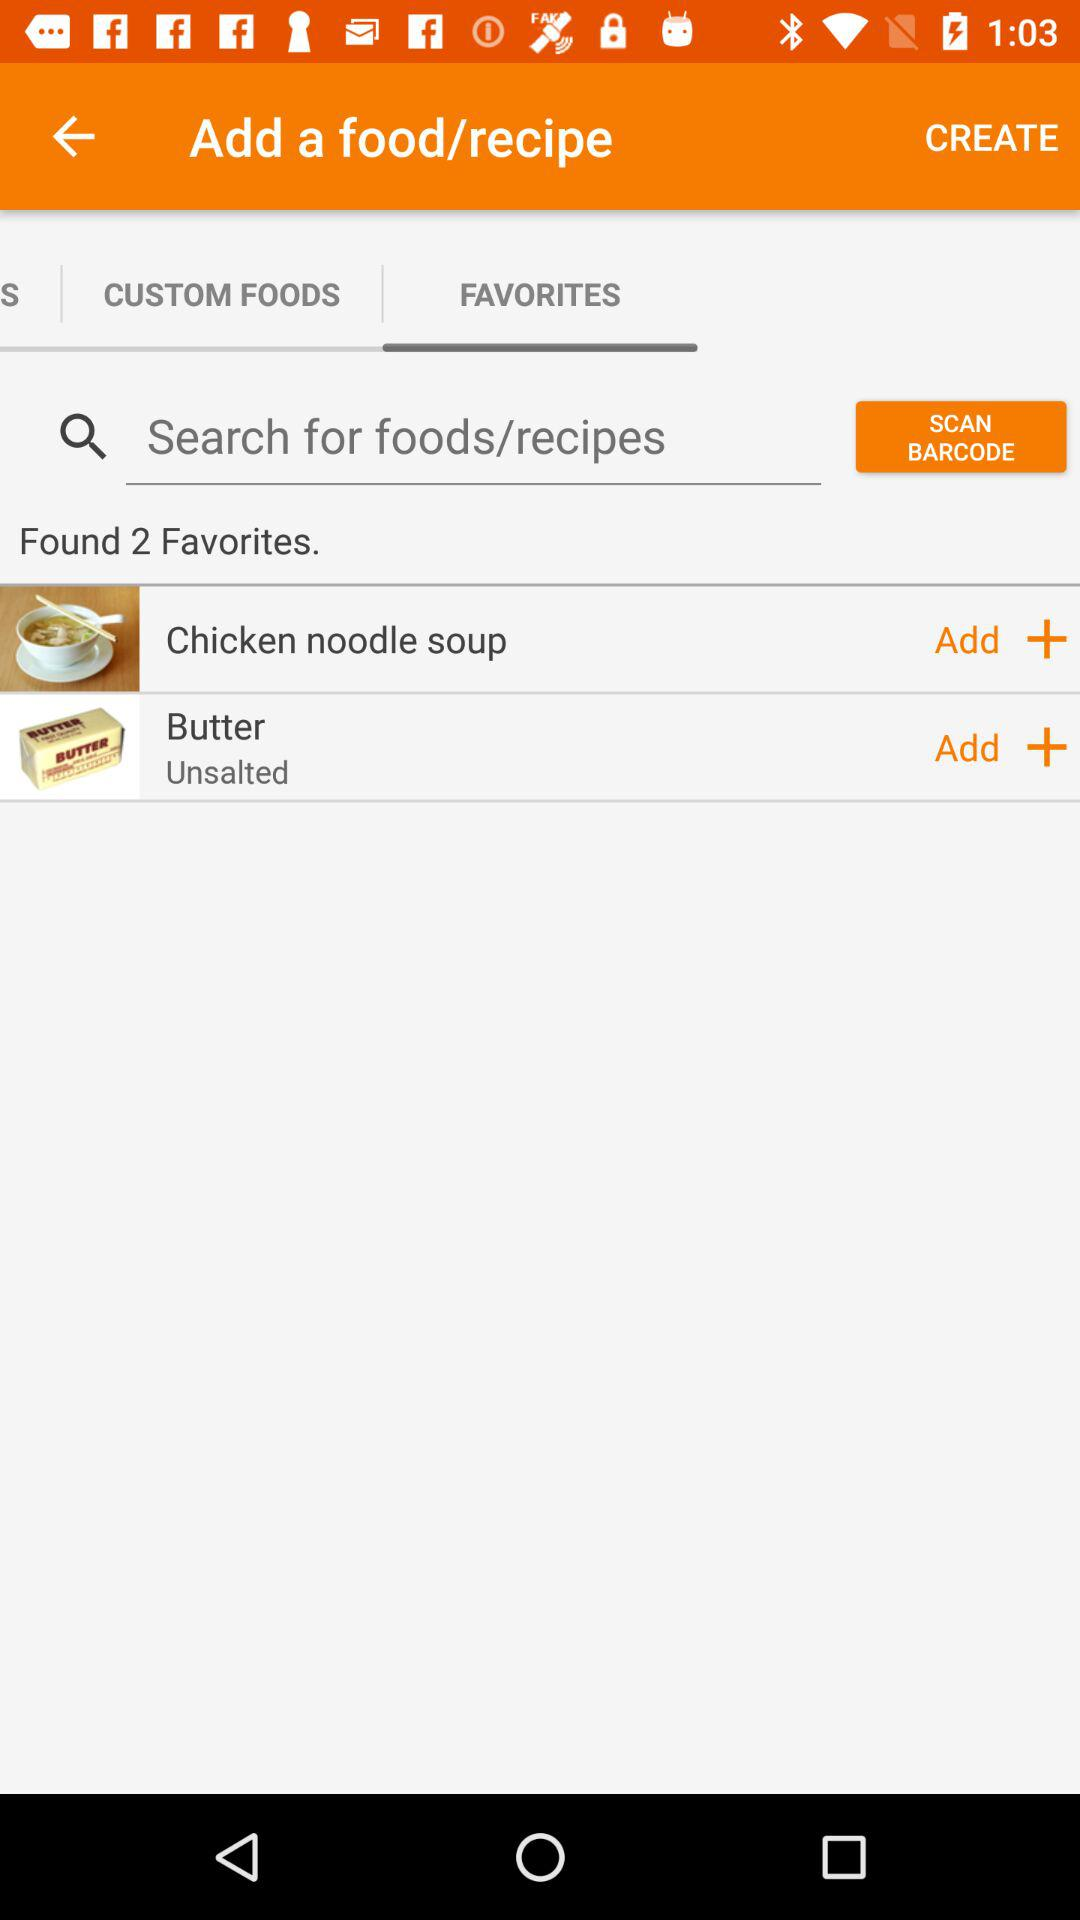How many favorite foods are there? There are 2 favorite foods. 